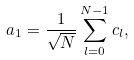Convert formula to latex. <formula><loc_0><loc_0><loc_500><loc_500>a _ { 1 } = \frac { 1 } { \sqrt { N } } \sum _ { l = 0 } ^ { N - 1 } c _ { l } ,</formula> 